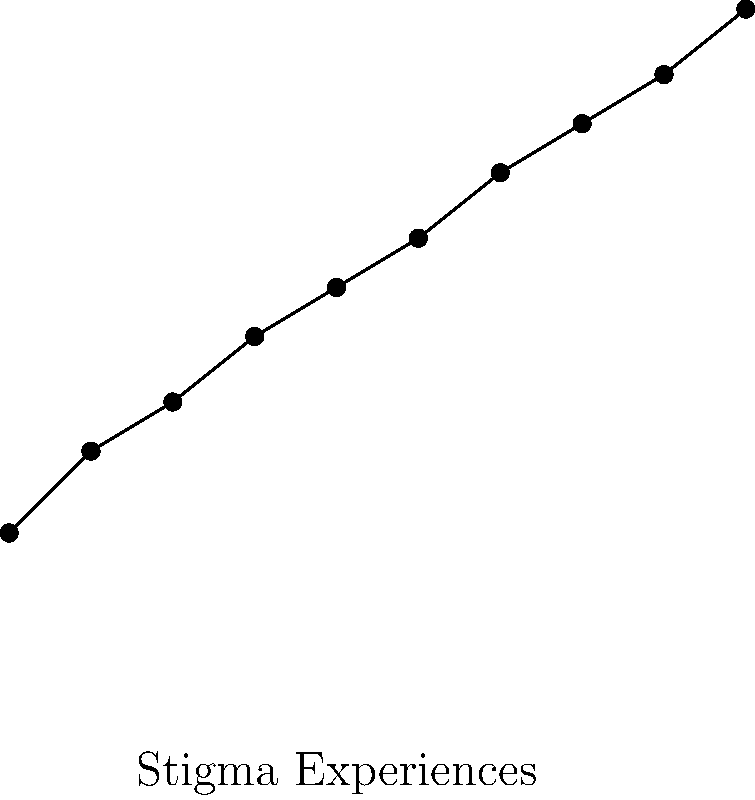Based on the scatter plot showing the relationship between stigma experiences and depression scores in people living with HIV/AIDS, what can be inferred about the correlation between these two variables? To analyze the correlation between stigma experiences and depression scores, we need to examine the scatter plot:

1. Direction: The points generally move from the bottom-left to the top-right of the graph. This indicates a positive relationship between stigma experiences and depression scores.

2. Strength: The points form a fairly tight pattern around an imaginary line. This suggests a strong correlation between the variables.

3. Linearity: The relationship appears to be approximately linear, as the points roughly follow a straight line.

4. Outliers: There don't appear to be any significant outliers that would skew the relationship.

5. Slope: The line of best fit (although not drawn) would have a positive slope, further confirming the positive correlation.

6. Range: As stigma experiences increase from 1 to 10, depression scores increase from about 10 to 42, showing a consistent upward trend.

Given these observations, we can conclude that there is a strong, positive, linear correlation between stigma experiences and depression scores in people living with HIV/AIDS. This suggests that as individuals experience more stigma, they tend to have higher depression scores.
Answer: Strong positive linear correlation 